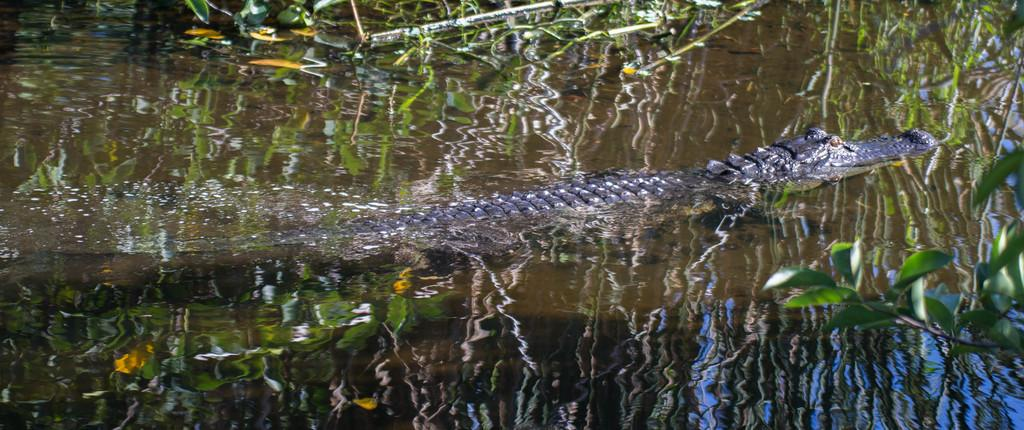What animal can be seen in the water in the image? There is a crocodile in the water in the image. What else can be seen in the water besides the crocodile? There are plants and leaves in the water. What is the consistency of the water in the image? There is mud in the water. How many different views of the crocodile can be seen in the image? There is only one view of the crocodile in the image, as it is a single image. 